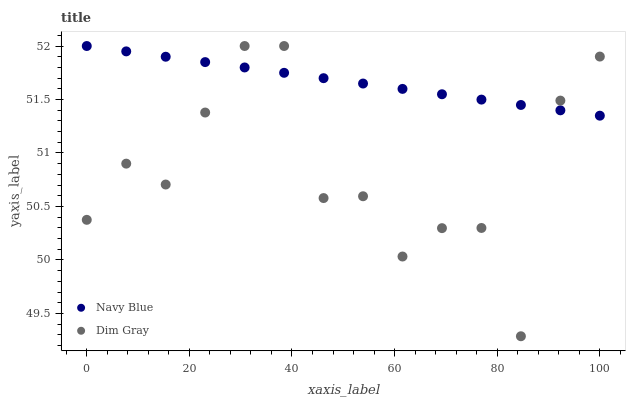Does Dim Gray have the minimum area under the curve?
Answer yes or no. Yes. Does Navy Blue have the maximum area under the curve?
Answer yes or no. Yes. Does Dim Gray have the maximum area under the curve?
Answer yes or no. No. Is Navy Blue the smoothest?
Answer yes or no. Yes. Is Dim Gray the roughest?
Answer yes or no. Yes. Is Dim Gray the smoothest?
Answer yes or no. No. Does Dim Gray have the lowest value?
Answer yes or no. Yes. Does Dim Gray have the highest value?
Answer yes or no. Yes. Does Navy Blue intersect Dim Gray?
Answer yes or no. Yes. Is Navy Blue less than Dim Gray?
Answer yes or no. No. Is Navy Blue greater than Dim Gray?
Answer yes or no. No. 